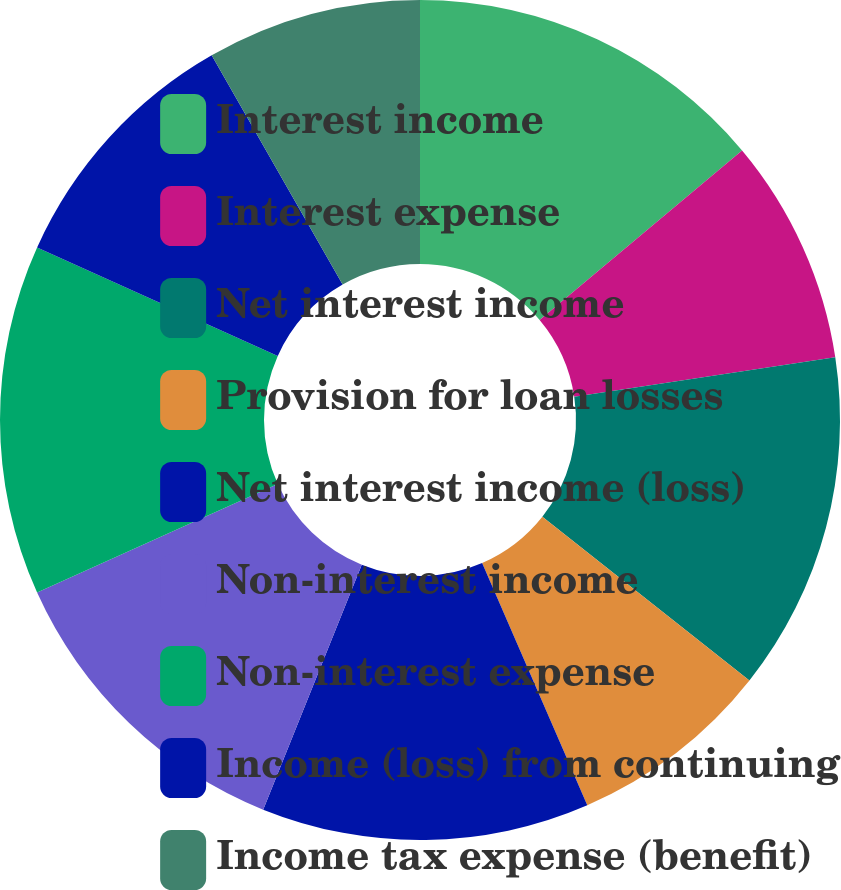Convert chart. <chart><loc_0><loc_0><loc_500><loc_500><pie_chart><fcel>Interest income<fcel>Interest expense<fcel>Net interest income<fcel>Provision for loan losses<fcel>Net interest income (loss)<fcel>Non-interest income<fcel>Non-interest expense<fcel>Income (loss) from continuing<fcel>Income tax expense (benefit)<nl><fcel>13.91%<fcel>8.7%<fcel>13.04%<fcel>7.83%<fcel>12.61%<fcel>12.17%<fcel>13.48%<fcel>10.0%<fcel>8.26%<nl></chart> 